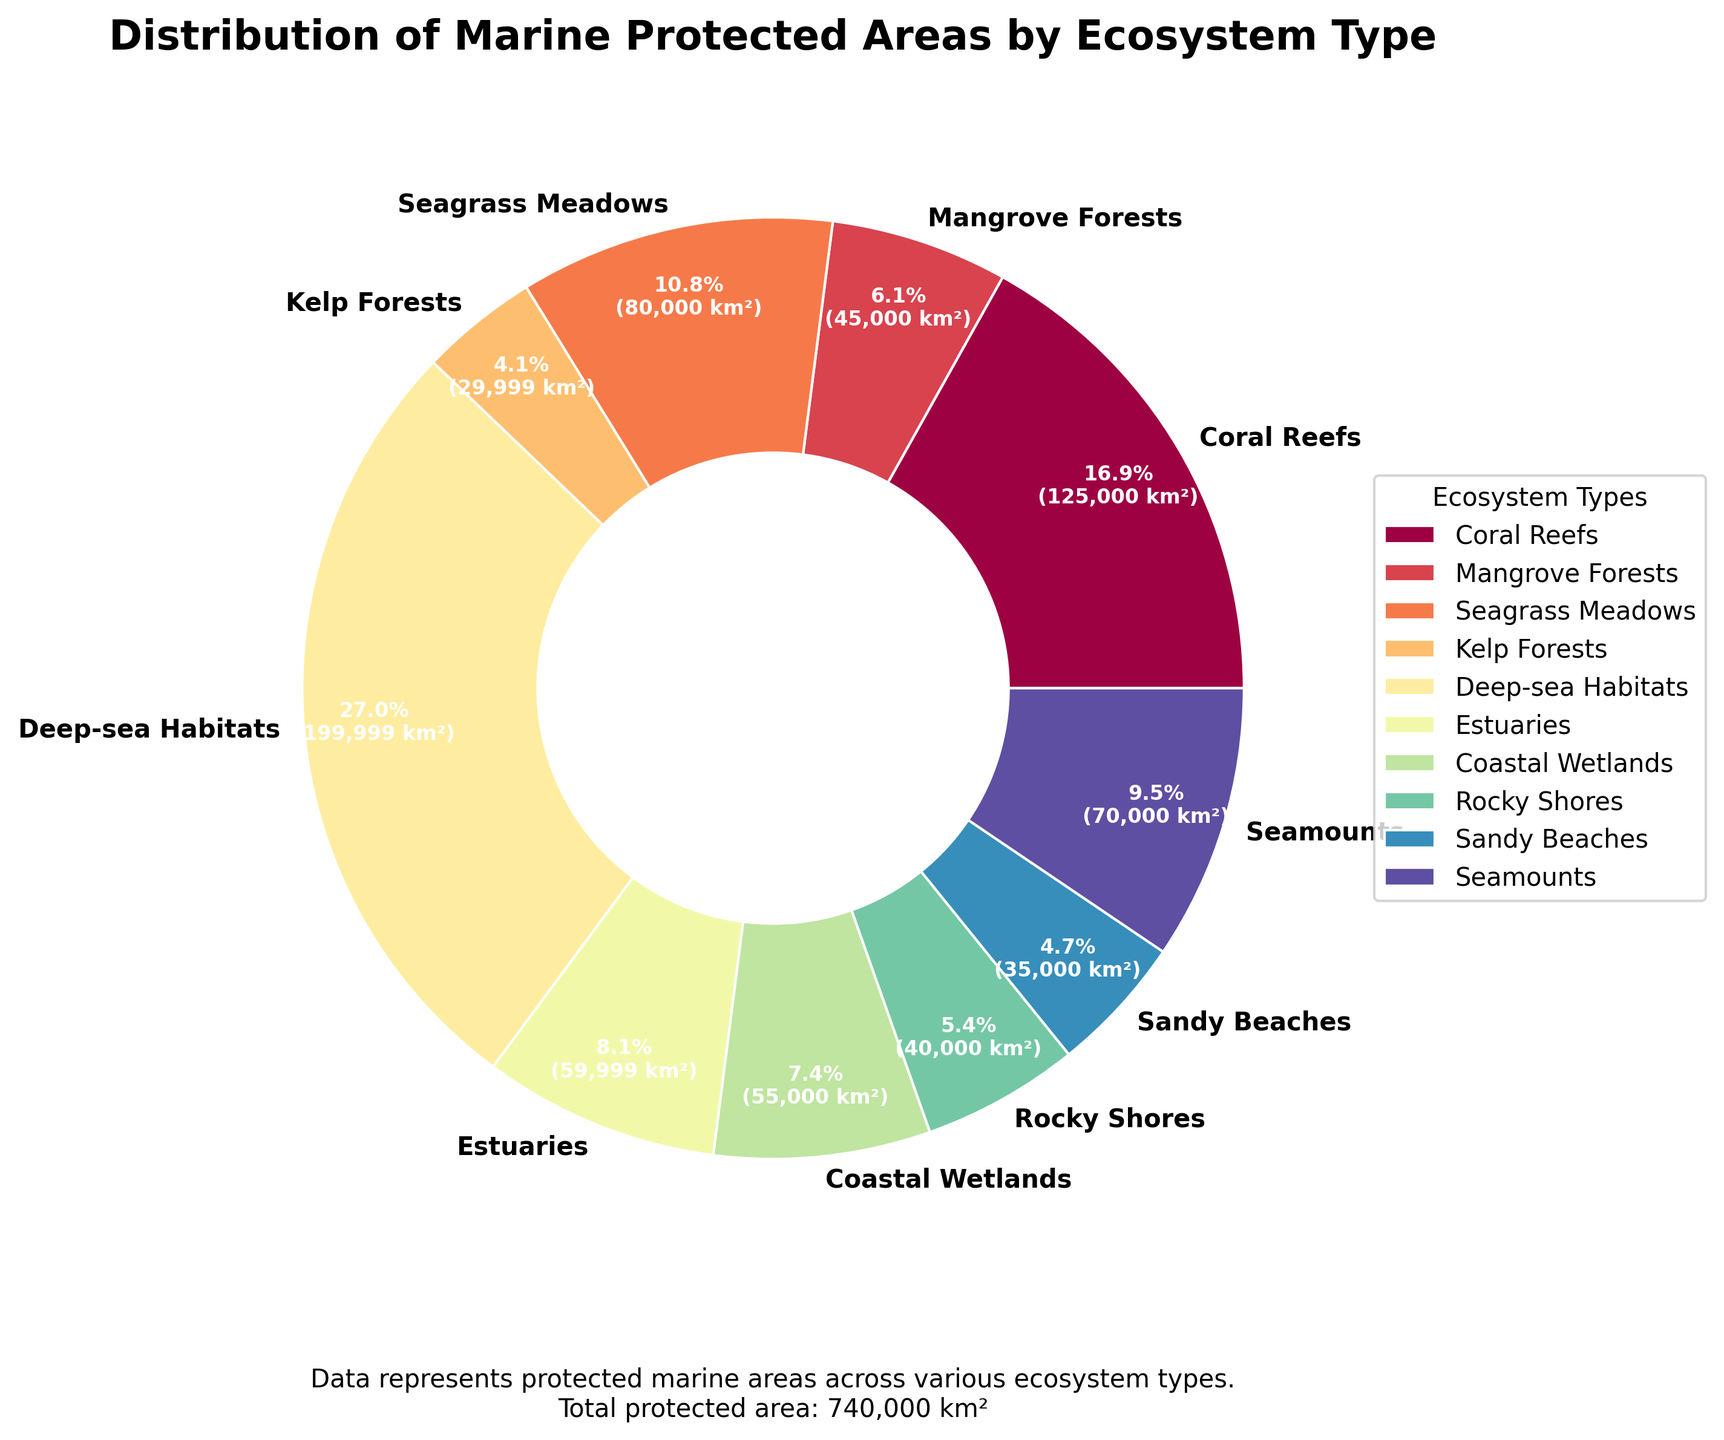Which ecosystem type has the largest protected area? To find the largest protected area, we refer to the percentage breakdown of the pie chart and the actual area values provided. Deep-sea Habitats has the largest section of the pie chart and its area is listed as 200,000 km².
Answer: Deep-sea Habitats What percentage of the total protected area is covered by Seamounts? By examining the pie chart, we see Seamounts' portion of the chart, which is 7.9%. Using the given data, Seamounts have a protected area of 70,000 km². Calculation: (70,000 / 680,000) * 100 = approximately 10.3%.
Answer: 10.3% How do the protected areas of Coral Reefs and Mangrove Forests compare? Inspecting the pie chart, Coral Reefs and Mangrove Forests' sections indicate that Coral Reefs have a larger area. Coral Reefs' area is 125,000 km², and Mangrove Forests is 45,000 km². Therefore, Coral Reefs have a significantly larger protected area.
Answer: Coral Reefs have a larger protected area What is the combined protected area of Seagrass Meadows and Estuaries in km²? The areas of Seagrass Meadows and Estuaries are 80,000 km² and 60,000 km² respectively. Adding these together, we get 80,000 km² + 60,000 km² = 140,000 km².
Answer: 140,000 km² How much more protected area does Deep-sea Habitats have compared to Kelp Forests in km²? According to the data, Deep-sea Habitats have an area of 200,000 km² and Kelp Forests have 30,000 km². The difference is 200,000 km² - 30,000 km² = 170,000 km².
Answer: 170,000 km² Which ecosystem type occupies the smallest percentage of the protected area? By observing the pie chart, Mangrove Forests have the smallest share of the pie chart. Mangrove Forests occupy 45,000 km² which is approximately 6.6% of the total protected area.
Answer: Mangrove Forests What is the total protected area covered by the three smallest ecosystem types? The smallest three ecosystem types by area are Mangrove Forests (45,000 km²), Sandy Beaches (35,000 km²), and Kelp Forests (30,000 km²). Summing these gives us 45,000 km² + 35,000 km² + 30,000 km² = 110,000 km².
Answer: 110,000 km² What percentage of the protected area is made up of Coral Reefs and Coastal Wetlands combined? Coral Reefs have an area of 125,000 km², and Coastal Wetlands have 55,000 km². The combined area is 125,000 km² + 55,000 km² = 180,000 km². Percentage calculation: (180,000 / 680,000) * 100 ≈ 26.5%.
Answer: 26.5% What visual cue indicates the size of ecosystem areas in the pie chart? The size of each wedge (arc length and area of each slice) in the pie chart visually represents the proportion of each ecosystem's protected area relative to the total protected area. Larger wedges signify larger areas.
Answer: Size of each wedge 